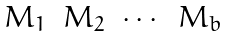<formula> <loc_0><loc_0><loc_500><loc_500>\begin{matrix} M _ { 1 } & M _ { 2 } & \cdots & M _ { b } \end{matrix}</formula> 